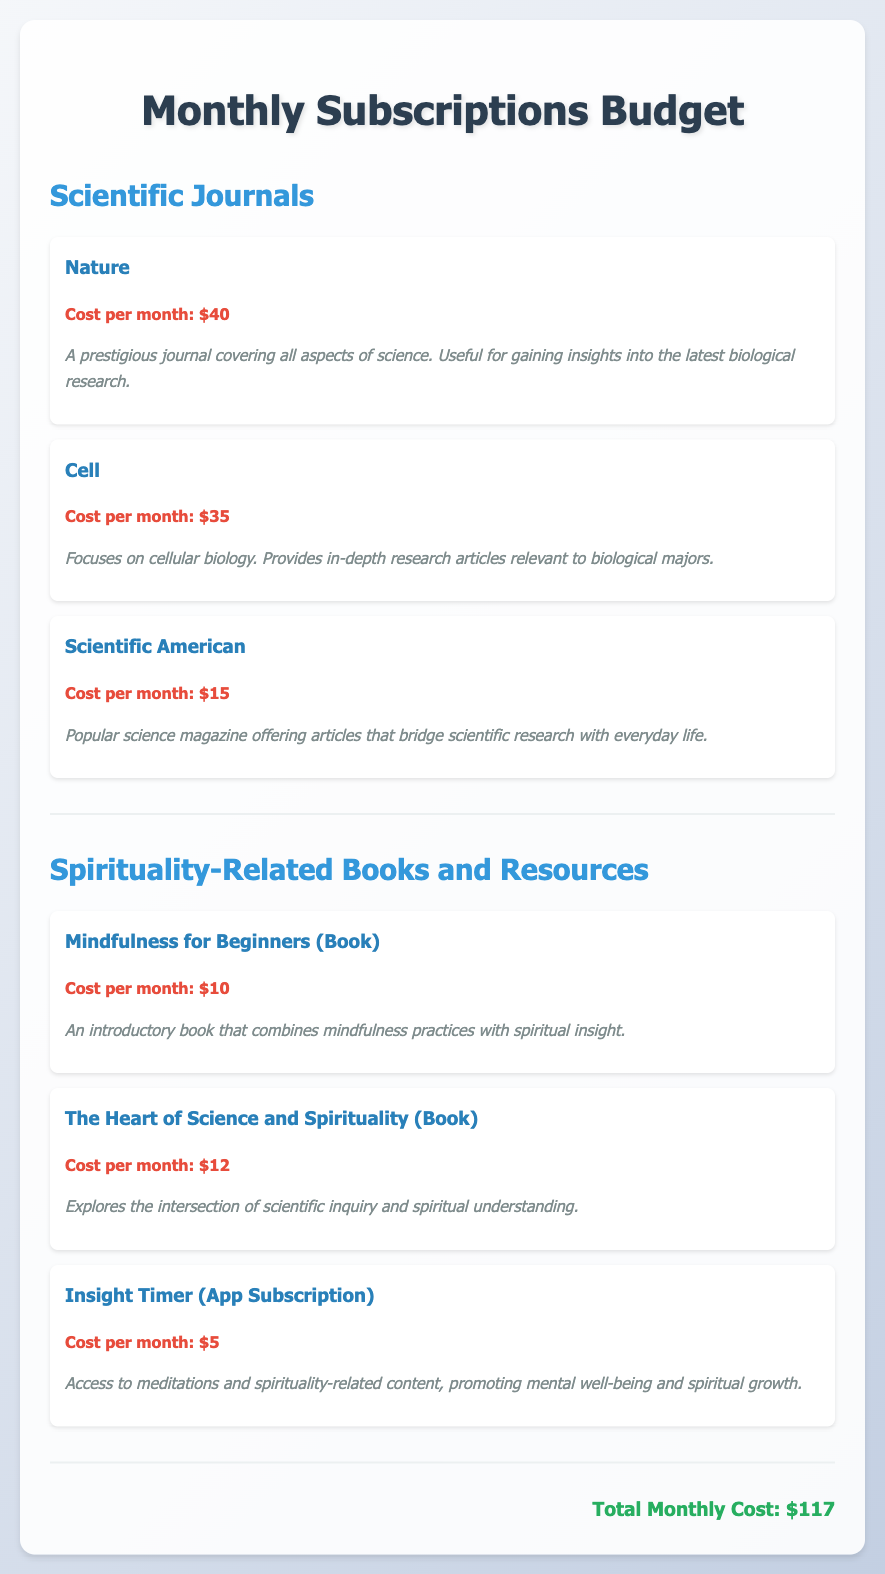what is the total monthly cost? The total monthly cost is the sum of all individual subscription costs listed in the document.
Answer: $117 how much is the subscription for Nature? Nature's subscription cost is specifically mentioned in the document.
Answer: $40 which journal focuses on cellular biology? The document provides the titles of scientific journals and their focus areas, identifying Cell as the one on cellular biology.
Answer: Cell what kind of content does Insight Timer provide? Insight Timer's description outlines the type of content available through its subscription.
Answer: Meditations and spirituality-related content how many spirituality-related resources are listed? The document lists individual spirituality-related resources, allowing for a straightforward count.
Answer: 3 what is the cost of the book "Mindfulness for Beginners"? The document explicitly states the cost for this book.
Answer: $10 which resource explores the intersection of science and spirituality? The provided descriptions allow identifying this resource, which discusses the connection between the two fields.
Answer: The Heart of Science and Spirituality what is the cost of the Scientific American subscription? The cost for the Scientific American subscription is specified in the document.
Answer: $15 how many scientific journals are mentioned? By counting the listed resources, one can find the number of scientific journals in the document.
Answer: 3 